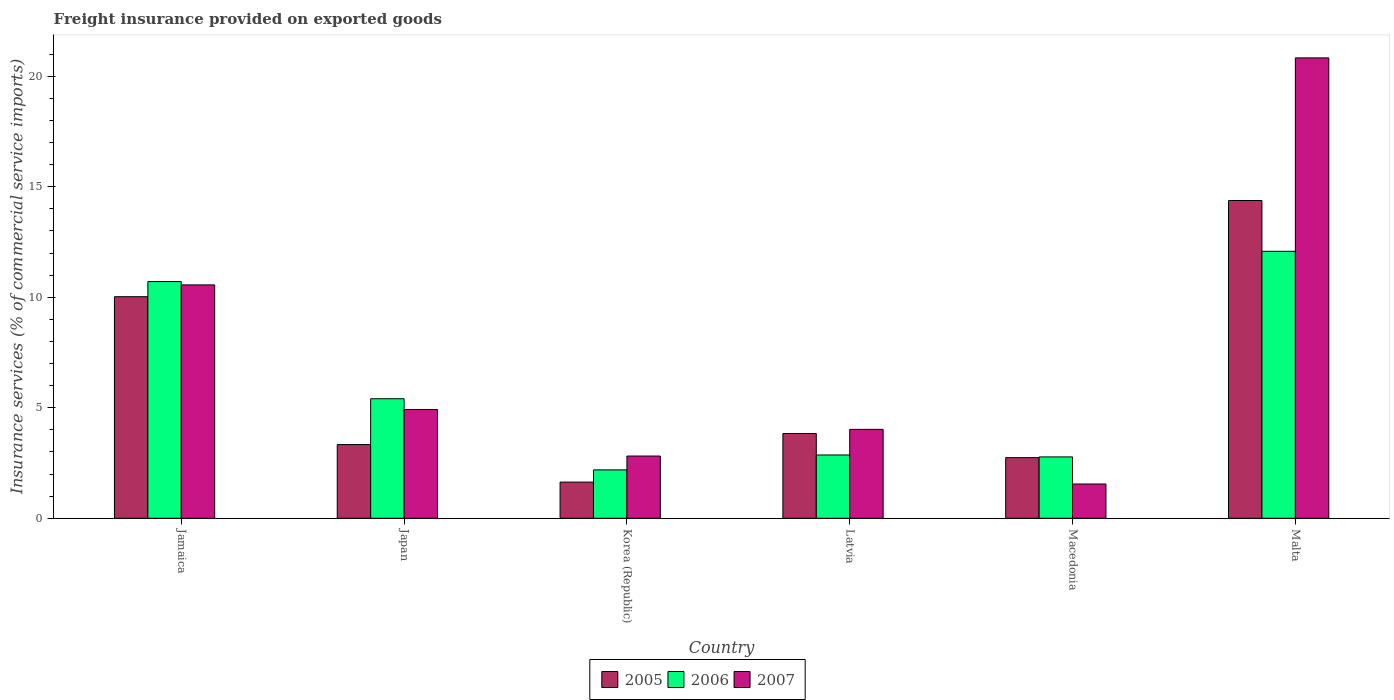Are the number of bars on each tick of the X-axis equal?
Offer a very short reply. Yes. How many bars are there on the 1st tick from the left?
Offer a very short reply. 3. How many bars are there on the 2nd tick from the right?
Give a very brief answer. 3. What is the label of the 6th group of bars from the left?
Provide a short and direct response. Malta. What is the freight insurance provided on exported goods in 2007 in Jamaica?
Provide a succinct answer. 10.56. Across all countries, what is the maximum freight insurance provided on exported goods in 2005?
Ensure brevity in your answer.  14.38. Across all countries, what is the minimum freight insurance provided on exported goods in 2006?
Make the answer very short. 2.19. In which country was the freight insurance provided on exported goods in 2005 maximum?
Provide a short and direct response. Malta. In which country was the freight insurance provided on exported goods in 2005 minimum?
Your answer should be very brief. Korea (Republic). What is the total freight insurance provided on exported goods in 2006 in the graph?
Offer a very short reply. 36.03. What is the difference between the freight insurance provided on exported goods in 2007 in Jamaica and that in Japan?
Ensure brevity in your answer.  5.64. What is the difference between the freight insurance provided on exported goods in 2006 in Malta and the freight insurance provided on exported goods in 2007 in Korea (Republic)?
Your answer should be very brief. 9.26. What is the average freight insurance provided on exported goods in 2006 per country?
Make the answer very short. 6.01. What is the difference between the freight insurance provided on exported goods of/in 2006 and freight insurance provided on exported goods of/in 2005 in Korea (Republic)?
Provide a short and direct response. 0.55. What is the ratio of the freight insurance provided on exported goods in 2007 in Macedonia to that in Malta?
Make the answer very short. 0.07. What is the difference between the highest and the second highest freight insurance provided on exported goods in 2006?
Offer a terse response. -1.37. What is the difference between the highest and the lowest freight insurance provided on exported goods in 2006?
Provide a short and direct response. 9.89. In how many countries, is the freight insurance provided on exported goods in 2007 greater than the average freight insurance provided on exported goods in 2007 taken over all countries?
Your response must be concise. 2. Is it the case that in every country, the sum of the freight insurance provided on exported goods in 2006 and freight insurance provided on exported goods in 2007 is greater than the freight insurance provided on exported goods in 2005?
Offer a terse response. Yes. How many bars are there?
Provide a succinct answer. 18. How many countries are there in the graph?
Your response must be concise. 6. What is the difference between two consecutive major ticks on the Y-axis?
Your answer should be very brief. 5. Does the graph contain any zero values?
Provide a short and direct response. No. Where does the legend appear in the graph?
Your response must be concise. Bottom center. How many legend labels are there?
Offer a terse response. 3. How are the legend labels stacked?
Make the answer very short. Horizontal. What is the title of the graph?
Provide a succinct answer. Freight insurance provided on exported goods. Does "2004" appear as one of the legend labels in the graph?
Your answer should be compact. No. What is the label or title of the X-axis?
Offer a terse response. Country. What is the label or title of the Y-axis?
Keep it short and to the point. Insurance services (% of commercial service imports). What is the Insurance services (% of commercial service imports) in 2005 in Jamaica?
Give a very brief answer. 10.03. What is the Insurance services (% of commercial service imports) in 2006 in Jamaica?
Provide a succinct answer. 10.71. What is the Insurance services (% of commercial service imports) in 2007 in Jamaica?
Your answer should be very brief. 10.56. What is the Insurance services (% of commercial service imports) in 2005 in Japan?
Provide a succinct answer. 3.34. What is the Insurance services (% of commercial service imports) in 2006 in Japan?
Your answer should be very brief. 5.41. What is the Insurance services (% of commercial service imports) of 2007 in Japan?
Offer a very short reply. 4.92. What is the Insurance services (% of commercial service imports) of 2005 in Korea (Republic)?
Provide a succinct answer. 1.64. What is the Insurance services (% of commercial service imports) of 2006 in Korea (Republic)?
Give a very brief answer. 2.19. What is the Insurance services (% of commercial service imports) in 2007 in Korea (Republic)?
Provide a short and direct response. 2.82. What is the Insurance services (% of commercial service imports) of 2005 in Latvia?
Offer a very short reply. 3.84. What is the Insurance services (% of commercial service imports) of 2006 in Latvia?
Ensure brevity in your answer.  2.86. What is the Insurance services (% of commercial service imports) in 2007 in Latvia?
Make the answer very short. 4.02. What is the Insurance services (% of commercial service imports) of 2005 in Macedonia?
Give a very brief answer. 2.74. What is the Insurance services (% of commercial service imports) in 2006 in Macedonia?
Ensure brevity in your answer.  2.78. What is the Insurance services (% of commercial service imports) in 2007 in Macedonia?
Provide a succinct answer. 1.55. What is the Insurance services (% of commercial service imports) of 2005 in Malta?
Keep it short and to the point. 14.38. What is the Insurance services (% of commercial service imports) in 2006 in Malta?
Provide a succinct answer. 12.08. What is the Insurance services (% of commercial service imports) in 2007 in Malta?
Keep it short and to the point. 20.83. Across all countries, what is the maximum Insurance services (% of commercial service imports) of 2005?
Provide a short and direct response. 14.38. Across all countries, what is the maximum Insurance services (% of commercial service imports) of 2006?
Provide a short and direct response. 12.08. Across all countries, what is the maximum Insurance services (% of commercial service imports) of 2007?
Offer a terse response. 20.83. Across all countries, what is the minimum Insurance services (% of commercial service imports) in 2005?
Offer a very short reply. 1.64. Across all countries, what is the minimum Insurance services (% of commercial service imports) in 2006?
Your answer should be compact. 2.19. Across all countries, what is the minimum Insurance services (% of commercial service imports) of 2007?
Give a very brief answer. 1.55. What is the total Insurance services (% of commercial service imports) of 2005 in the graph?
Keep it short and to the point. 35.95. What is the total Insurance services (% of commercial service imports) in 2006 in the graph?
Your answer should be very brief. 36.03. What is the total Insurance services (% of commercial service imports) in 2007 in the graph?
Offer a very short reply. 44.7. What is the difference between the Insurance services (% of commercial service imports) in 2005 in Jamaica and that in Japan?
Provide a succinct answer. 6.69. What is the difference between the Insurance services (% of commercial service imports) in 2006 in Jamaica and that in Japan?
Give a very brief answer. 5.3. What is the difference between the Insurance services (% of commercial service imports) of 2007 in Jamaica and that in Japan?
Offer a very short reply. 5.64. What is the difference between the Insurance services (% of commercial service imports) of 2005 in Jamaica and that in Korea (Republic)?
Your answer should be very brief. 8.39. What is the difference between the Insurance services (% of commercial service imports) in 2006 in Jamaica and that in Korea (Republic)?
Make the answer very short. 8.52. What is the difference between the Insurance services (% of commercial service imports) of 2007 in Jamaica and that in Korea (Republic)?
Offer a terse response. 7.74. What is the difference between the Insurance services (% of commercial service imports) in 2005 in Jamaica and that in Latvia?
Your response must be concise. 6.19. What is the difference between the Insurance services (% of commercial service imports) in 2006 in Jamaica and that in Latvia?
Provide a succinct answer. 7.85. What is the difference between the Insurance services (% of commercial service imports) of 2007 in Jamaica and that in Latvia?
Offer a terse response. 6.54. What is the difference between the Insurance services (% of commercial service imports) in 2005 in Jamaica and that in Macedonia?
Your response must be concise. 7.28. What is the difference between the Insurance services (% of commercial service imports) of 2006 in Jamaica and that in Macedonia?
Provide a short and direct response. 7.93. What is the difference between the Insurance services (% of commercial service imports) in 2007 in Jamaica and that in Macedonia?
Give a very brief answer. 9.01. What is the difference between the Insurance services (% of commercial service imports) of 2005 in Jamaica and that in Malta?
Offer a terse response. -4.35. What is the difference between the Insurance services (% of commercial service imports) of 2006 in Jamaica and that in Malta?
Provide a short and direct response. -1.37. What is the difference between the Insurance services (% of commercial service imports) of 2007 in Jamaica and that in Malta?
Your answer should be compact. -10.27. What is the difference between the Insurance services (% of commercial service imports) in 2005 in Japan and that in Korea (Republic)?
Offer a very short reply. 1.7. What is the difference between the Insurance services (% of commercial service imports) in 2006 in Japan and that in Korea (Republic)?
Your answer should be compact. 3.22. What is the difference between the Insurance services (% of commercial service imports) in 2007 in Japan and that in Korea (Republic)?
Offer a terse response. 2.11. What is the difference between the Insurance services (% of commercial service imports) of 2005 in Japan and that in Latvia?
Ensure brevity in your answer.  -0.5. What is the difference between the Insurance services (% of commercial service imports) of 2006 in Japan and that in Latvia?
Your answer should be very brief. 2.55. What is the difference between the Insurance services (% of commercial service imports) of 2007 in Japan and that in Latvia?
Offer a very short reply. 0.9. What is the difference between the Insurance services (% of commercial service imports) of 2005 in Japan and that in Macedonia?
Provide a succinct answer. 0.59. What is the difference between the Insurance services (% of commercial service imports) of 2006 in Japan and that in Macedonia?
Provide a succinct answer. 2.63. What is the difference between the Insurance services (% of commercial service imports) of 2007 in Japan and that in Macedonia?
Offer a very short reply. 3.37. What is the difference between the Insurance services (% of commercial service imports) in 2005 in Japan and that in Malta?
Ensure brevity in your answer.  -11.04. What is the difference between the Insurance services (% of commercial service imports) in 2006 in Japan and that in Malta?
Provide a short and direct response. -6.67. What is the difference between the Insurance services (% of commercial service imports) in 2007 in Japan and that in Malta?
Ensure brevity in your answer.  -15.91. What is the difference between the Insurance services (% of commercial service imports) of 2005 in Korea (Republic) and that in Latvia?
Provide a succinct answer. -2.2. What is the difference between the Insurance services (% of commercial service imports) of 2006 in Korea (Republic) and that in Latvia?
Provide a short and direct response. -0.67. What is the difference between the Insurance services (% of commercial service imports) of 2007 in Korea (Republic) and that in Latvia?
Provide a short and direct response. -1.21. What is the difference between the Insurance services (% of commercial service imports) of 2005 in Korea (Republic) and that in Macedonia?
Your answer should be very brief. -1.11. What is the difference between the Insurance services (% of commercial service imports) of 2006 in Korea (Republic) and that in Macedonia?
Offer a terse response. -0.59. What is the difference between the Insurance services (% of commercial service imports) in 2007 in Korea (Republic) and that in Macedonia?
Provide a short and direct response. 1.27. What is the difference between the Insurance services (% of commercial service imports) in 2005 in Korea (Republic) and that in Malta?
Keep it short and to the point. -12.74. What is the difference between the Insurance services (% of commercial service imports) of 2006 in Korea (Republic) and that in Malta?
Provide a short and direct response. -9.89. What is the difference between the Insurance services (% of commercial service imports) in 2007 in Korea (Republic) and that in Malta?
Provide a succinct answer. -18.02. What is the difference between the Insurance services (% of commercial service imports) in 2005 in Latvia and that in Macedonia?
Keep it short and to the point. 1.09. What is the difference between the Insurance services (% of commercial service imports) in 2006 in Latvia and that in Macedonia?
Make the answer very short. 0.09. What is the difference between the Insurance services (% of commercial service imports) of 2007 in Latvia and that in Macedonia?
Your response must be concise. 2.47. What is the difference between the Insurance services (% of commercial service imports) in 2005 in Latvia and that in Malta?
Your answer should be compact. -10.54. What is the difference between the Insurance services (% of commercial service imports) in 2006 in Latvia and that in Malta?
Provide a succinct answer. -9.22. What is the difference between the Insurance services (% of commercial service imports) in 2007 in Latvia and that in Malta?
Offer a terse response. -16.81. What is the difference between the Insurance services (% of commercial service imports) in 2005 in Macedonia and that in Malta?
Provide a succinct answer. -11.64. What is the difference between the Insurance services (% of commercial service imports) of 2006 in Macedonia and that in Malta?
Your answer should be compact. -9.3. What is the difference between the Insurance services (% of commercial service imports) of 2007 in Macedonia and that in Malta?
Provide a succinct answer. -19.28. What is the difference between the Insurance services (% of commercial service imports) in 2005 in Jamaica and the Insurance services (% of commercial service imports) in 2006 in Japan?
Your response must be concise. 4.62. What is the difference between the Insurance services (% of commercial service imports) of 2005 in Jamaica and the Insurance services (% of commercial service imports) of 2007 in Japan?
Offer a very short reply. 5.1. What is the difference between the Insurance services (% of commercial service imports) of 2006 in Jamaica and the Insurance services (% of commercial service imports) of 2007 in Japan?
Keep it short and to the point. 5.79. What is the difference between the Insurance services (% of commercial service imports) of 2005 in Jamaica and the Insurance services (% of commercial service imports) of 2006 in Korea (Republic)?
Give a very brief answer. 7.84. What is the difference between the Insurance services (% of commercial service imports) in 2005 in Jamaica and the Insurance services (% of commercial service imports) in 2007 in Korea (Republic)?
Your answer should be very brief. 7.21. What is the difference between the Insurance services (% of commercial service imports) in 2006 in Jamaica and the Insurance services (% of commercial service imports) in 2007 in Korea (Republic)?
Provide a short and direct response. 7.89. What is the difference between the Insurance services (% of commercial service imports) of 2005 in Jamaica and the Insurance services (% of commercial service imports) of 2006 in Latvia?
Your answer should be very brief. 7.16. What is the difference between the Insurance services (% of commercial service imports) in 2005 in Jamaica and the Insurance services (% of commercial service imports) in 2007 in Latvia?
Your answer should be very brief. 6. What is the difference between the Insurance services (% of commercial service imports) in 2006 in Jamaica and the Insurance services (% of commercial service imports) in 2007 in Latvia?
Provide a succinct answer. 6.69. What is the difference between the Insurance services (% of commercial service imports) of 2005 in Jamaica and the Insurance services (% of commercial service imports) of 2006 in Macedonia?
Offer a very short reply. 7.25. What is the difference between the Insurance services (% of commercial service imports) of 2005 in Jamaica and the Insurance services (% of commercial service imports) of 2007 in Macedonia?
Your answer should be compact. 8.48. What is the difference between the Insurance services (% of commercial service imports) in 2006 in Jamaica and the Insurance services (% of commercial service imports) in 2007 in Macedonia?
Ensure brevity in your answer.  9.16. What is the difference between the Insurance services (% of commercial service imports) of 2005 in Jamaica and the Insurance services (% of commercial service imports) of 2006 in Malta?
Offer a terse response. -2.05. What is the difference between the Insurance services (% of commercial service imports) in 2005 in Jamaica and the Insurance services (% of commercial service imports) in 2007 in Malta?
Ensure brevity in your answer.  -10.81. What is the difference between the Insurance services (% of commercial service imports) of 2006 in Jamaica and the Insurance services (% of commercial service imports) of 2007 in Malta?
Offer a very short reply. -10.12. What is the difference between the Insurance services (% of commercial service imports) of 2005 in Japan and the Insurance services (% of commercial service imports) of 2006 in Korea (Republic)?
Your answer should be very brief. 1.15. What is the difference between the Insurance services (% of commercial service imports) in 2005 in Japan and the Insurance services (% of commercial service imports) in 2007 in Korea (Republic)?
Your answer should be compact. 0.52. What is the difference between the Insurance services (% of commercial service imports) in 2006 in Japan and the Insurance services (% of commercial service imports) in 2007 in Korea (Republic)?
Provide a succinct answer. 2.59. What is the difference between the Insurance services (% of commercial service imports) in 2005 in Japan and the Insurance services (% of commercial service imports) in 2006 in Latvia?
Offer a very short reply. 0.47. What is the difference between the Insurance services (% of commercial service imports) of 2005 in Japan and the Insurance services (% of commercial service imports) of 2007 in Latvia?
Ensure brevity in your answer.  -0.69. What is the difference between the Insurance services (% of commercial service imports) in 2006 in Japan and the Insurance services (% of commercial service imports) in 2007 in Latvia?
Keep it short and to the point. 1.39. What is the difference between the Insurance services (% of commercial service imports) in 2005 in Japan and the Insurance services (% of commercial service imports) in 2006 in Macedonia?
Keep it short and to the point. 0.56. What is the difference between the Insurance services (% of commercial service imports) in 2005 in Japan and the Insurance services (% of commercial service imports) in 2007 in Macedonia?
Give a very brief answer. 1.78. What is the difference between the Insurance services (% of commercial service imports) in 2006 in Japan and the Insurance services (% of commercial service imports) in 2007 in Macedonia?
Offer a very short reply. 3.86. What is the difference between the Insurance services (% of commercial service imports) in 2005 in Japan and the Insurance services (% of commercial service imports) in 2006 in Malta?
Your response must be concise. -8.75. What is the difference between the Insurance services (% of commercial service imports) in 2005 in Japan and the Insurance services (% of commercial service imports) in 2007 in Malta?
Make the answer very short. -17.5. What is the difference between the Insurance services (% of commercial service imports) in 2006 in Japan and the Insurance services (% of commercial service imports) in 2007 in Malta?
Offer a very short reply. -15.42. What is the difference between the Insurance services (% of commercial service imports) of 2005 in Korea (Republic) and the Insurance services (% of commercial service imports) of 2006 in Latvia?
Your answer should be compact. -1.23. What is the difference between the Insurance services (% of commercial service imports) of 2005 in Korea (Republic) and the Insurance services (% of commercial service imports) of 2007 in Latvia?
Your answer should be compact. -2.39. What is the difference between the Insurance services (% of commercial service imports) of 2006 in Korea (Republic) and the Insurance services (% of commercial service imports) of 2007 in Latvia?
Your response must be concise. -1.83. What is the difference between the Insurance services (% of commercial service imports) of 2005 in Korea (Republic) and the Insurance services (% of commercial service imports) of 2006 in Macedonia?
Ensure brevity in your answer.  -1.14. What is the difference between the Insurance services (% of commercial service imports) in 2005 in Korea (Republic) and the Insurance services (% of commercial service imports) in 2007 in Macedonia?
Make the answer very short. 0.09. What is the difference between the Insurance services (% of commercial service imports) of 2006 in Korea (Republic) and the Insurance services (% of commercial service imports) of 2007 in Macedonia?
Keep it short and to the point. 0.64. What is the difference between the Insurance services (% of commercial service imports) of 2005 in Korea (Republic) and the Insurance services (% of commercial service imports) of 2006 in Malta?
Give a very brief answer. -10.44. What is the difference between the Insurance services (% of commercial service imports) in 2005 in Korea (Republic) and the Insurance services (% of commercial service imports) in 2007 in Malta?
Make the answer very short. -19.19. What is the difference between the Insurance services (% of commercial service imports) in 2006 in Korea (Republic) and the Insurance services (% of commercial service imports) in 2007 in Malta?
Your answer should be compact. -18.64. What is the difference between the Insurance services (% of commercial service imports) of 2005 in Latvia and the Insurance services (% of commercial service imports) of 2006 in Macedonia?
Your answer should be very brief. 1.06. What is the difference between the Insurance services (% of commercial service imports) of 2005 in Latvia and the Insurance services (% of commercial service imports) of 2007 in Macedonia?
Provide a succinct answer. 2.29. What is the difference between the Insurance services (% of commercial service imports) in 2006 in Latvia and the Insurance services (% of commercial service imports) in 2007 in Macedonia?
Ensure brevity in your answer.  1.31. What is the difference between the Insurance services (% of commercial service imports) in 2005 in Latvia and the Insurance services (% of commercial service imports) in 2006 in Malta?
Offer a terse response. -8.24. What is the difference between the Insurance services (% of commercial service imports) of 2005 in Latvia and the Insurance services (% of commercial service imports) of 2007 in Malta?
Your response must be concise. -17. What is the difference between the Insurance services (% of commercial service imports) of 2006 in Latvia and the Insurance services (% of commercial service imports) of 2007 in Malta?
Your response must be concise. -17.97. What is the difference between the Insurance services (% of commercial service imports) of 2005 in Macedonia and the Insurance services (% of commercial service imports) of 2006 in Malta?
Keep it short and to the point. -9.34. What is the difference between the Insurance services (% of commercial service imports) in 2005 in Macedonia and the Insurance services (% of commercial service imports) in 2007 in Malta?
Make the answer very short. -18.09. What is the difference between the Insurance services (% of commercial service imports) of 2006 in Macedonia and the Insurance services (% of commercial service imports) of 2007 in Malta?
Your answer should be very brief. -18.05. What is the average Insurance services (% of commercial service imports) in 2005 per country?
Your answer should be very brief. 5.99. What is the average Insurance services (% of commercial service imports) in 2006 per country?
Your response must be concise. 6.01. What is the average Insurance services (% of commercial service imports) of 2007 per country?
Offer a very short reply. 7.45. What is the difference between the Insurance services (% of commercial service imports) in 2005 and Insurance services (% of commercial service imports) in 2006 in Jamaica?
Keep it short and to the point. -0.68. What is the difference between the Insurance services (% of commercial service imports) of 2005 and Insurance services (% of commercial service imports) of 2007 in Jamaica?
Keep it short and to the point. -0.53. What is the difference between the Insurance services (% of commercial service imports) of 2006 and Insurance services (% of commercial service imports) of 2007 in Jamaica?
Your answer should be very brief. 0.15. What is the difference between the Insurance services (% of commercial service imports) in 2005 and Insurance services (% of commercial service imports) in 2006 in Japan?
Provide a succinct answer. -2.07. What is the difference between the Insurance services (% of commercial service imports) of 2005 and Insurance services (% of commercial service imports) of 2007 in Japan?
Your answer should be very brief. -1.59. What is the difference between the Insurance services (% of commercial service imports) of 2006 and Insurance services (% of commercial service imports) of 2007 in Japan?
Make the answer very short. 0.49. What is the difference between the Insurance services (% of commercial service imports) in 2005 and Insurance services (% of commercial service imports) in 2006 in Korea (Republic)?
Ensure brevity in your answer.  -0.55. What is the difference between the Insurance services (% of commercial service imports) of 2005 and Insurance services (% of commercial service imports) of 2007 in Korea (Republic)?
Keep it short and to the point. -1.18. What is the difference between the Insurance services (% of commercial service imports) in 2006 and Insurance services (% of commercial service imports) in 2007 in Korea (Republic)?
Offer a terse response. -0.63. What is the difference between the Insurance services (% of commercial service imports) in 2005 and Insurance services (% of commercial service imports) in 2006 in Latvia?
Offer a terse response. 0.97. What is the difference between the Insurance services (% of commercial service imports) of 2005 and Insurance services (% of commercial service imports) of 2007 in Latvia?
Provide a short and direct response. -0.19. What is the difference between the Insurance services (% of commercial service imports) of 2006 and Insurance services (% of commercial service imports) of 2007 in Latvia?
Your response must be concise. -1.16. What is the difference between the Insurance services (% of commercial service imports) of 2005 and Insurance services (% of commercial service imports) of 2006 in Macedonia?
Your answer should be compact. -0.03. What is the difference between the Insurance services (% of commercial service imports) in 2005 and Insurance services (% of commercial service imports) in 2007 in Macedonia?
Keep it short and to the point. 1.19. What is the difference between the Insurance services (% of commercial service imports) of 2006 and Insurance services (% of commercial service imports) of 2007 in Macedonia?
Ensure brevity in your answer.  1.23. What is the difference between the Insurance services (% of commercial service imports) in 2005 and Insurance services (% of commercial service imports) in 2006 in Malta?
Your answer should be compact. 2.3. What is the difference between the Insurance services (% of commercial service imports) in 2005 and Insurance services (% of commercial service imports) in 2007 in Malta?
Offer a very short reply. -6.45. What is the difference between the Insurance services (% of commercial service imports) in 2006 and Insurance services (% of commercial service imports) in 2007 in Malta?
Your answer should be compact. -8.75. What is the ratio of the Insurance services (% of commercial service imports) in 2005 in Jamaica to that in Japan?
Provide a short and direct response. 3.01. What is the ratio of the Insurance services (% of commercial service imports) of 2006 in Jamaica to that in Japan?
Provide a short and direct response. 1.98. What is the ratio of the Insurance services (% of commercial service imports) of 2007 in Jamaica to that in Japan?
Make the answer very short. 2.15. What is the ratio of the Insurance services (% of commercial service imports) of 2005 in Jamaica to that in Korea (Republic)?
Give a very brief answer. 6.13. What is the ratio of the Insurance services (% of commercial service imports) in 2006 in Jamaica to that in Korea (Republic)?
Your answer should be compact. 4.89. What is the ratio of the Insurance services (% of commercial service imports) of 2007 in Jamaica to that in Korea (Republic)?
Keep it short and to the point. 3.75. What is the ratio of the Insurance services (% of commercial service imports) of 2005 in Jamaica to that in Latvia?
Give a very brief answer. 2.61. What is the ratio of the Insurance services (% of commercial service imports) in 2006 in Jamaica to that in Latvia?
Give a very brief answer. 3.74. What is the ratio of the Insurance services (% of commercial service imports) in 2007 in Jamaica to that in Latvia?
Your answer should be very brief. 2.63. What is the ratio of the Insurance services (% of commercial service imports) of 2005 in Jamaica to that in Macedonia?
Provide a succinct answer. 3.66. What is the ratio of the Insurance services (% of commercial service imports) of 2006 in Jamaica to that in Macedonia?
Your response must be concise. 3.86. What is the ratio of the Insurance services (% of commercial service imports) in 2007 in Jamaica to that in Macedonia?
Your answer should be compact. 6.81. What is the ratio of the Insurance services (% of commercial service imports) in 2005 in Jamaica to that in Malta?
Keep it short and to the point. 0.7. What is the ratio of the Insurance services (% of commercial service imports) in 2006 in Jamaica to that in Malta?
Your answer should be very brief. 0.89. What is the ratio of the Insurance services (% of commercial service imports) of 2007 in Jamaica to that in Malta?
Give a very brief answer. 0.51. What is the ratio of the Insurance services (% of commercial service imports) in 2005 in Japan to that in Korea (Republic)?
Offer a terse response. 2.04. What is the ratio of the Insurance services (% of commercial service imports) of 2006 in Japan to that in Korea (Republic)?
Offer a very short reply. 2.47. What is the ratio of the Insurance services (% of commercial service imports) of 2007 in Japan to that in Korea (Republic)?
Ensure brevity in your answer.  1.75. What is the ratio of the Insurance services (% of commercial service imports) of 2005 in Japan to that in Latvia?
Give a very brief answer. 0.87. What is the ratio of the Insurance services (% of commercial service imports) in 2006 in Japan to that in Latvia?
Offer a very short reply. 1.89. What is the ratio of the Insurance services (% of commercial service imports) in 2007 in Japan to that in Latvia?
Provide a short and direct response. 1.22. What is the ratio of the Insurance services (% of commercial service imports) of 2005 in Japan to that in Macedonia?
Your answer should be compact. 1.22. What is the ratio of the Insurance services (% of commercial service imports) in 2006 in Japan to that in Macedonia?
Give a very brief answer. 1.95. What is the ratio of the Insurance services (% of commercial service imports) in 2007 in Japan to that in Macedonia?
Provide a succinct answer. 3.18. What is the ratio of the Insurance services (% of commercial service imports) of 2005 in Japan to that in Malta?
Make the answer very short. 0.23. What is the ratio of the Insurance services (% of commercial service imports) of 2006 in Japan to that in Malta?
Provide a succinct answer. 0.45. What is the ratio of the Insurance services (% of commercial service imports) of 2007 in Japan to that in Malta?
Provide a succinct answer. 0.24. What is the ratio of the Insurance services (% of commercial service imports) in 2005 in Korea (Republic) to that in Latvia?
Keep it short and to the point. 0.43. What is the ratio of the Insurance services (% of commercial service imports) of 2006 in Korea (Republic) to that in Latvia?
Provide a short and direct response. 0.76. What is the ratio of the Insurance services (% of commercial service imports) in 2007 in Korea (Republic) to that in Latvia?
Keep it short and to the point. 0.7. What is the ratio of the Insurance services (% of commercial service imports) in 2005 in Korea (Republic) to that in Macedonia?
Your answer should be very brief. 0.6. What is the ratio of the Insurance services (% of commercial service imports) of 2006 in Korea (Republic) to that in Macedonia?
Provide a succinct answer. 0.79. What is the ratio of the Insurance services (% of commercial service imports) of 2007 in Korea (Republic) to that in Macedonia?
Your answer should be very brief. 1.82. What is the ratio of the Insurance services (% of commercial service imports) of 2005 in Korea (Republic) to that in Malta?
Ensure brevity in your answer.  0.11. What is the ratio of the Insurance services (% of commercial service imports) of 2006 in Korea (Republic) to that in Malta?
Offer a terse response. 0.18. What is the ratio of the Insurance services (% of commercial service imports) in 2007 in Korea (Republic) to that in Malta?
Your answer should be compact. 0.14. What is the ratio of the Insurance services (% of commercial service imports) in 2005 in Latvia to that in Macedonia?
Provide a succinct answer. 1.4. What is the ratio of the Insurance services (% of commercial service imports) of 2006 in Latvia to that in Macedonia?
Your answer should be very brief. 1.03. What is the ratio of the Insurance services (% of commercial service imports) in 2007 in Latvia to that in Macedonia?
Offer a very short reply. 2.59. What is the ratio of the Insurance services (% of commercial service imports) of 2005 in Latvia to that in Malta?
Keep it short and to the point. 0.27. What is the ratio of the Insurance services (% of commercial service imports) of 2006 in Latvia to that in Malta?
Make the answer very short. 0.24. What is the ratio of the Insurance services (% of commercial service imports) of 2007 in Latvia to that in Malta?
Provide a short and direct response. 0.19. What is the ratio of the Insurance services (% of commercial service imports) of 2005 in Macedonia to that in Malta?
Ensure brevity in your answer.  0.19. What is the ratio of the Insurance services (% of commercial service imports) of 2006 in Macedonia to that in Malta?
Provide a short and direct response. 0.23. What is the ratio of the Insurance services (% of commercial service imports) in 2007 in Macedonia to that in Malta?
Your answer should be compact. 0.07. What is the difference between the highest and the second highest Insurance services (% of commercial service imports) in 2005?
Provide a short and direct response. 4.35. What is the difference between the highest and the second highest Insurance services (% of commercial service imports) in 2006?
Offer a very short reply. 1.37. What is the difference between the highest and the second highest Insurance services (% of commercial service imports) of 2007?
Offer a terse response. 10.27. What is the difference between the highest and the lowest Insurance services (% of commercial service imports) of 2005?
Keep it short and to the point. 12.74. What is the difference between the highest and the lowest Insurance services (% of commercial service imports) in 2006?
Your answer should be compact. 9.89. What is the difference between the highest and the lowest Insurance services (% of commercial service imports) in 2007?
Offer a terse response. 19.28. 